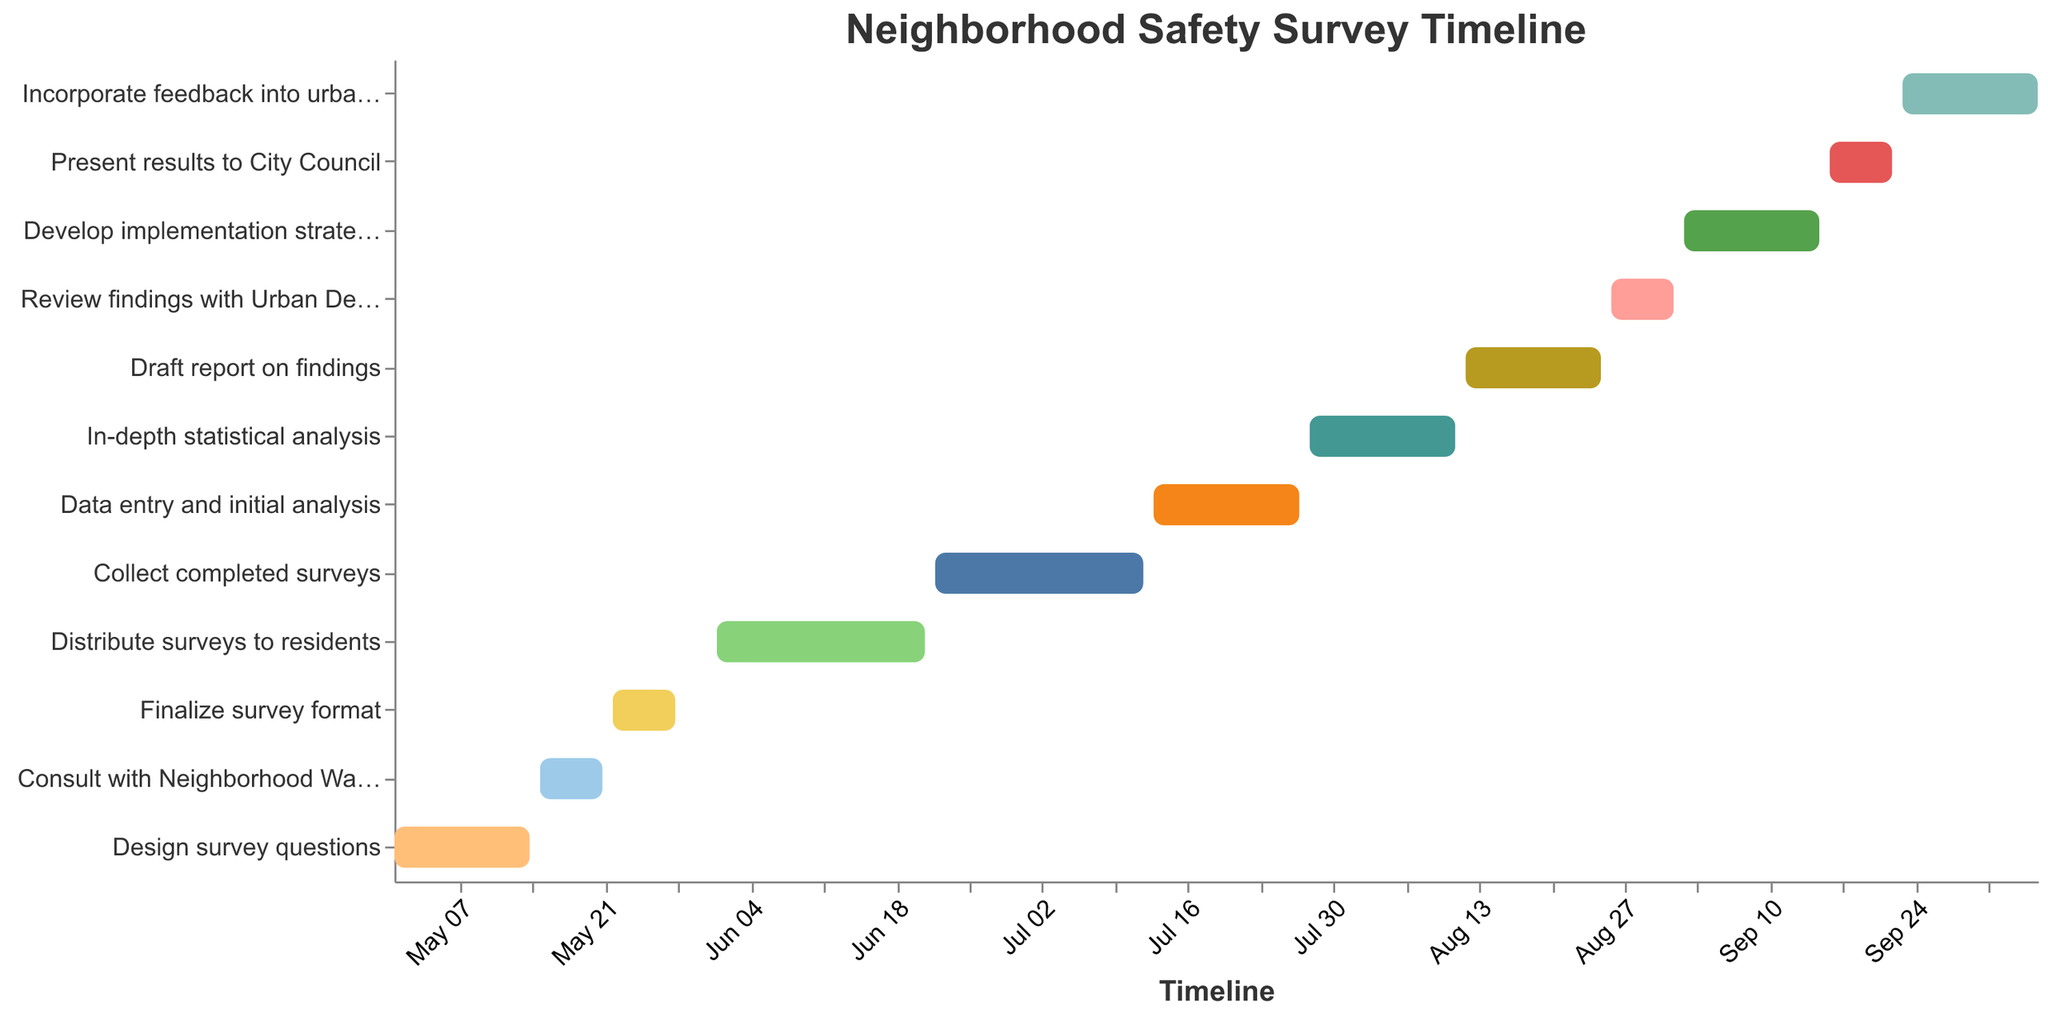What is the start date for the task "Collect completed surveys"? Look for the bar corresponding to "Collect completed surveys" and refer to its start date on the x-axis.
Answer: June 22, 2023 What is the end date for finalizing the survey format? Find the bar labeled "Finalize survey format" and note its end date on the x-axis.
Answer: May 28, 2023 How long is the task "Data entry and initial analysis"? Determine the duration by noting the start and end dates: July 13, 2023, to July 27, 2023. The difference between these dates is 15 days.
Answer: 15 days Which task ends the latest date, and when is it? Compare the end dates of all tasks and identify the one that has the latest end date. The bar "Incorporate feedback into urban design plans" ends the latest.
Answer: October 6, 2023 How many days does the in-depth statistical analysis take? Note the start and end dates for "In-depth statistical analysis": July 28, 2023, to August 11, 2023. Count the days between these dates.
Answer: 15 days Which task has a longer duration: "Draft report on findings" or "Consult with Neighborhood Watch Coordinator"? Compare the durations based on the start and end dates: 
- "Draft report on findings": August 12, 2023, to August 25, 2023 (14 days) 
- "Consult with Neighborhood Watch Coordinator": May 15, 2023, to May 21, 2023 (7 days) 
The first task is longer.
Answer: Draft report on findings What tasks should be completed by the end of July 2023? Identify tasks whose end dates are on or before July 31, 2023. These include:
- "Design survey questions" (May 14, 2023)
- "Consult with Neighborhood Watch Coordinator" (May 21, 2023)
- "Finalize survey format" (May 28, 2023)
- "Distribute surveys to residents" (June 21, 2023)
- "Collect completed surveys" (July 12, 2023)
- "Data entry and initial analysis" (July 27, 2023)
Answer: Six tasks (Design survey questions, Consult with Neighborhood Watch Coordinator, Finalize survey format, Distribute surveys to residents, Collect completed surveys, Data entry and initial analysis) Which task is directly followed by "Distribute surveys to residents"? Refer to the chronological order in the timeline, and note that "Distribute surveys to residents" is immediately followed by "Collect completed surveys."
Answer: Collect completed surveys What is the duration of the entire project from the start of the first task to the end of the last task? Find the start date of the first task ("Design survey questions": May 1, 2023) and the end date of the last task ("Incorporate feedback into urban design plans": October 6, 2023). The duration can be calculated as the number of days between these two dates (October 6, 2023 - May 1, 2023 is 159 days).
Answer: 159 Days Which tasks overlap in the month of August 2023? Identify overlapping tasks by their start and end dates in August:
- "In-depth statistical analysis" (ends August 11, 2023)
- "Draft report on findings" (August 12, 2023, to August 25, 2023)
- "Review findings with Urban Design Team" (August 26, 2023, to September 1, 2023)
These tasks overlap sequentially over the month of August.
Answer: In-depth statistical analysis, Draft report on findings, Review findings with Urban Design Team 